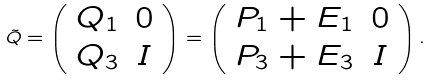<formula> <loc_0><loc_0><loc_500><loc_500>\tilde { Q } = \left ( \begin{array} { c c } Q _ { 1 } & 0 \\ Q _ { 3 } & I \end{array} \right ) = \left ( \begin{array} { c c } P _ { 1 } + E _ { 1 } & 0 \\ P _ { 3 } + E _ { 3 } & I \end{array} \right ) .</formula> 